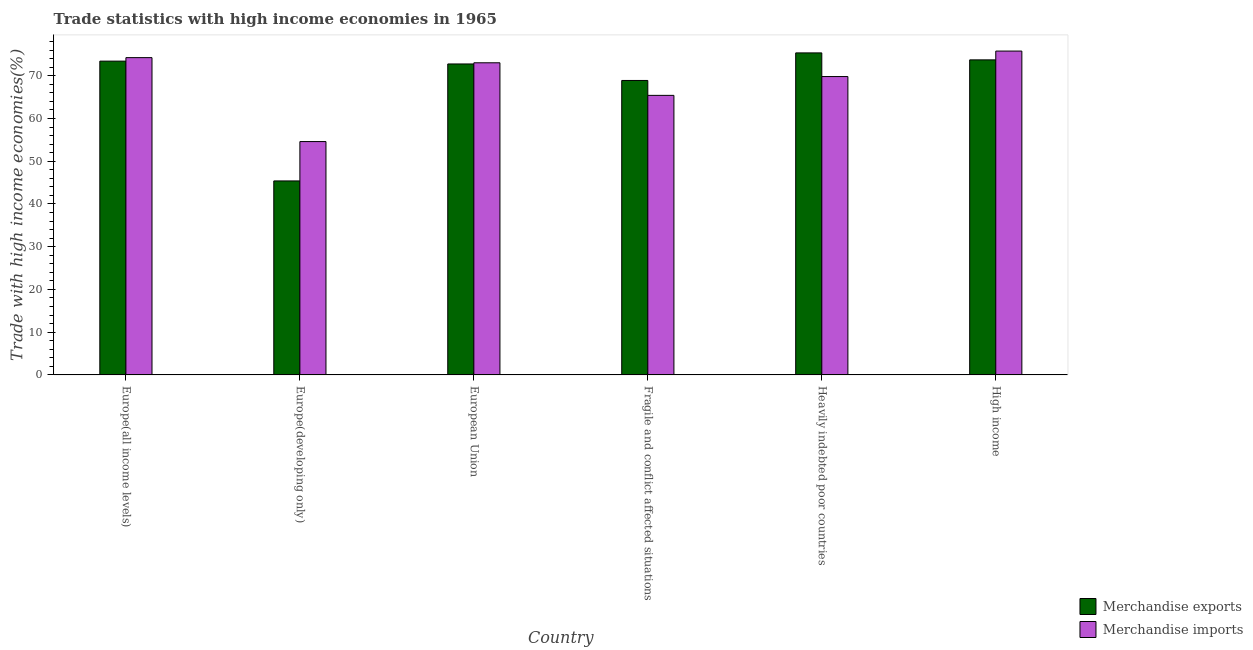How many groups of bars are there?
Your answer should be compact. 6. Are the number of bars per tick equal to the number of legend labels?
Provide a short and direct response. Yes. How many bars are there on the 2nd tick from the right?
Your answer should be compact. 2. What is the label of the 2nd group of bars from the left?
Give a very brief answer. Europe(developing only). What is the merchandise imports in Heavily indebted poor countries?
Your answer should be very brief. 69.82. Across all countries, what is the maximum merchandise imports?
Your answer should be compact. 75.78. Across all countries, what is the minimum merchandise imports?
Give a very brief answer. 54.6. In which country was the merchandise imports minimum?
Your answer should be very brief. Europe(developing only). What is the total merchandise exports in the graph?
Provide a short and direct response. 409.57. What is the difference between the merchandise exports in Europe(all income levels) and that in Europe(developing only)?
Your answer should be very brief. 28.04. What is the difference between the merchandise imports in Europe(all income levels) and the merchandise exports in Europe(developing only)?
Ensure brevity in your answer.  28.85. What is the average merchandise imports per country?
Provide a succinct answer. 68.82. What is the difference between the merchandise imports and merchandise exports in High income?
Offer a terse response. 2.06. What is the ratio of the merchandise exports in Europe(all income levels) to that in European Union?
Provide a succinct answer. 1.01. Is the difference between the merchandise exports in Europe(all income levels) and Europe(developing only) greater than the difference between the merchandise imports in Europe(all income levels) and Europe(developing only)?
Your answer should be very brief. Yes. What is the difference between the highest and the second highest merchandise imports?
Ensure brevity in your answer.  1.54. What is the difference between the highest and the lowest merchandise exports?
Make the answer very short. 29.96. Is the sum of the merchandise imports in European Union and High income greater than the maximum merchandise exports across all countries?
Your response must be concise. Yes. Are the values on the major ticks of Y-axis written in scientific E-notation?
Make the answer very short. No. How many legend labels are there?
Provide a short and direct response. 2. What is the title of the graph?
Offer a very short reply. Trade statistics with high income economies in 1965. What is the label or title of the Y-axis?
Your response must be concise. Trade with high income economies(%). What is the Trade with high income economies(%) in Merchandise exports in Europe(all income levels)?
Ensure brevity in your answer.  73.43. What is the Trade with high income economies(%) in Merchandise imports in Europe(all income levels)?
Keep it short and to the point. 74.25. What is the Trade with high income economies(%) of Merchandise exports in Europe(developing only)?
Ensure brevity in your answer.  45.39. What is the Trade with high income economies(%) of Merchandise imports in Europe(developing only)?
Your response must be concise. 54.6. What is the Trade with high income economies(%) of Merchandise exports in European Union?
Your answer should be very brief. 72.77. What is the Trade with high income economies(%) of Merchandise imports in European Union?
Your response must be concise. 73.04. What is the Trade with high income economies(%) of Merchandise exports in Fragile and conflict affected situations?
Your answer should be compact. 68.9. What is the Trade with high income economies(%) of Merchandise imports in Fragile and conflict affected situations?
Give a very brief answer. 65.42. What is the Trade with high income economies(%) of Merchandise exports in Heavily indebted poor countries?
Offer a very short reply. 75.35. What is the Trade with high income economies(%) of Merchandise imports in Heavily indebted poor countries?
Make the answer very short. 69.82. What is the Trade with high income economies(%) of Merchandise exports in High income?
Offer a terse response. 73.72. What is the Trade with high income economies(%) of Merchandise imports in High income?
Offer a very short reply. 75.78. Across all countries, what is the maximum Trade with high income economies(%) of Merchandise exports?
Offer a terse response. 75.35. Across all countries, what is the maximum Trade with high income economies(%) of Merchandise imports?
Your response must be concise. 75.78. Across all countries, what is the minimum Trade with high income economies(%) of Merchandise exports?
Provide a short and direct response. 45.39. Across all countries, what is the minimum Trade with high income economies(%) in Merchandise imports?
Ensure brevity in your answer.  54.6. What is the total Trade with high income economies(%) of Merchandise exports in the graph?
Your answer should be compact. 409.57. What is the total Trade with high income economies(%) of Merchandise imports in the graph?
Keep it short and to the point. 412.91. What is the difference between the Trade with high income economies(%) in Merchandise exports in Europe(all income levels) and that in Europe(developing only)?
Keep it short and to the point. 28.04. What is the difference between the Trade with high income economies(%) in Merchandise imports in Europe(all income levels) and that in Europe(developing only)?
Offer a very short reply. 19.64. What is the difference between the Trade with high income economies(%) in Merchandise exports in Europe(all income levels) and that in European Union?
Give a very brief answer. 0.66. What is the difference between the Trade with high income economies(%) of Merchandise imports in Europe(all income levels) and that in European Union?
Ensure brevity in your answer.  1.2. What is the difference between the Trade with high income economies(%) of Merchandise exports in Europe(all income levels) and that in Fragile and conflict affected situations?
Your answer should be very brief. 4.52. What is the difference between the Trade with high income economies(%) of Merchandise imports in Europe(all income levels) and that in Fragile and conflict affected situations?
Keep it short and to the point. 8.83. What is the difference between the Trade with high income economies(%) of Merchandise exports in Europe(all income levels) and that in Heavily indebted poor countries?
Provide a succinct answer. -1.93. What is the difference between the Trade with high income economies(%) of Merchandise imports in Europe(all income levels) and that in Heavily indebted poor countries?
Your answer should be very brief. 4.43. What is the difference between the Trade with high income economies(%) of Merchandise exports in Europe(all income levels) and that in High income?
Your response must be concise. -0.29. What is the difference between the Trade with high income economies(%) of Merchandise imports in Europe(all income levels) and that in High income?
Give a very brief answer. -1.54. What is the difference between the Trade with high income economies(%) in Merchandise exports in Europe(developing only) and that in European Union?
Give a very brief answer. -27.37. What is the difference between the Trade with high income economies(%) in Merchandise imports in Europe(developing only) and that in European Union?
Your response must be concise. -18.44. What is the difference between the Trade with high income economies(%) of Merchandise exports in Europe(developing only) and that in Fragile and conflict affected situations?
Offer a very short reply. -23.51. What is the difference between the Trade with high income economies(%) in Merchandise imports in Europe(developing only) and that in Fragile and conflict affected situations?
Provide a succinct answer. -10.81. What is the difference between the Trade with high income economies(%) in Merchandise exports in Europe(developing only) and that in Heavily indebted poor countries?
Your response must be concise. -29.96. What is the difference between the Trade with high income economies(%) of Merchandise imports in Europe(developing only) and that in Heavily indebted poor countries?
Provide a short and direct response. -15.22. What is the difference between the Trade with high income economies(%) of Merchandise exports in Europe(developing only) and that in High income?
Keep it short and to the point. -28.33. What is the difference between the Trade with high income economies(%) of Merchandise imports in Europe(developing only) and that in High income?
Your answer should be compact. -21.18. What is the difference between the Trade with high income economies(%) of Merchandise exports in European Union and that in Fragile and conflict affected situations?
Your answer should be compact. 3.86. What is the difference between the Trade with high income economies(%) in Merchandise imports in European Union and that in Fragile and conflict affected situations?
Keep it short and to the point. 7.62. What is the difference between the Trade with high income economies(%) in Merchandise exports in European Union and that in Heavily indebted poor countries?
Provide a short and direct response. -2.59. What is the difference between the Trade with high income economies(%) of Merchandise imports in European Union and that in Heavily indebted poor countries?
Make the answer very short. 3.22. What is the difference between the Trade with high income economies(%) of Merchandise exports in European Union and that in High income?
Keep it short and to the point. -0.96. What is the difference between the Trade with high income economies(%) in Merchandise imports in European Union and that in High income?
Your response must be concise. -2.74. What is the difference between the Trade with high income economies(%) of Merchandise exports in Fragile and conflict affected situations and that in Heavily indebted poor countries?
Make the answer very short. -6.45. What is the difference between the Trade with high income economies(%) of Merchandise imports in Fragile and conflict affected situations and that in Heavily indebted poor countries?
Ensure brevity in your answer.  -4.4. What is the difference between the Trade with high income economies(%) in Merchandise exports in Fragile and conflict affected situations and that in High income?
Provide a short and direct response. -4.82. What is the difference between the Trade with high income economies(%) of Merchandise imports in Fragile and conflict affected situations and that in High income?
Provide a short and direct response. -10.37. What is the difference between the Trade with high income economies(%) of Merchandise exports in Heavily indebted poor countries and that in High income?
Your answer should be compact. 1.63. What is the difference between the Trade with high income economies(%) of Merchandise imports in Heavily indebted poor countries and that in High income?
Offer a terse response. -5.96. What is the difference between the Trade with high income economies(%) in Merchandise exports in Europe(all income levels) and the Trade with high income economies(%) in Merchandise imports in Europe(developing only)?
Make the answer very short. 18.82. What is the difference between the Trade with high income economies(%) in Merchandise exports in Europe(all income levels) and the Trade with high income economies(%) in Merchandise imports in European Union?
Your answer should be compact. 0.39. What is the difference between the Trade with high income economies(%) of Merchandise exports in Europe(all income levels) and the Trade with high income economies(%) of Merchandise imports in Fragile and conflict affected situations?
Provide a short and direct response. 8.01. What is the difference between the Trade with high income economies(%) in Merchandise exports in Europe(all income levels) and the Trade with high income economies(%) in Merchandise imports in Heavily indebted poor countries?
Keep it short and to the point. 3.61. What is the difference between the Trade with high income economies(%) of Merchandise exports in Europe(all income levels) and the Trade with high income economies(%) of Merchandise imports in High income?
Offer a terse response. -2.35. What is the difference between the Trade with high income economies(%) in Merchandise exports in Europe(developing only) and the Trade with high income economies(%) in Merchandise imports in European Union?
Your response must be concise. -27.65. What is the difference between the Trade with high income economies(%) in Merchandise exports in Europe(developing only) and the Trade with high income economies(%) in Merchandise imports in Fragile and conflict affected situations?
Provide a succinct answer. -20.02. What is the difference between the Trade with high income economies(%) in Merchandise exports in Europe(developing only) and the Trade with high income economies(%) in Merchandise imports in Heavily indebted poor countries?
Your answer should be compact. -24.43. What is the difference between the Trade with high income economies(%) in Merchandise exports in Europe(developing only) and the Trade with high income economies(%) in Merchandise imports in High income?
Keep it short and to the point. -30.39. What is the difference between the Trade with high income economies(%) in Merchandise exports in European Union and the Trade with high income economies(%) in Merchandise imports in Fragile and conflict affected situations?
Ensure brevity in your answer.  7.35. What is the difference between the Trade with high income economies(%) of Merchandise exports in European Union and the Trade with high income economies(%) of Merchandise imports in Heavily indebted poor countries?
Your response must be concise. 2.95. What is the difference between the Trade with high income economies(%) in Merchandise exports in European Union and the Trade with high income economies(%) in Merchandise imports in High income?
Your answer should be compact. -3.02. What is the difference between the Trade with high income economies(%) of Merchandise exports in Fragile and conflict affected situations and the Trade with high income economies(%) of Merchandise imports in Heavily indebted poor countries?
Your response must be concise. -0.92. What is the difference between the Trade with high income economies(%) of Merchandise exports in Fragile and conflict affected situations and the Trade with high income economies(%) of Merchandise imports in High income?
Ensure brevity in your answer.  -6.88. What is the difference between the Trade with high income economies(%) in Merchandise exports in Heavily indebted poor countries and the Trade with high income economies(%) in Merchandise imports in High income?
Your answer should be very brief. -0.43. What is the average Trade with high income economies(%) in Merchandise exports per country?
Your answer should be very brief. 68.26. What is the average Trade with high income economies(%) of Merchandise imports per country?
Keep it short and to the point. 68.82. What is the difference between the Trade with high income economies(%) in Merchandise exports and Trade with high income economies(%) in Merchandise imports in Europe(all income levels)?
Offer a terse response. -0.82. What is the difference between the Trade with high income economies(%) of Merchandise exports and Trade with high income economies(%) of Merchandise imports in Europe(developing only)?
Keep it short and to the point. -9.21. What is the difference between the Trade with high income economies(%) in Merchandise exports and Trade with high income economies(%) in Merchandise imports in European Union?
Provide a short and direct response. -0.27. What is the difference between the Trade with high income economies(%) of Merchandise exports and Trade with high income economies(%) of Merchandise imports in Fragile and conflict affected situations?
Make the answer very short. 3.49. What is the difference between the Trade with high income economies(%) of Merchandise exports and Trade with high income economies(%) of Merchandise imports in Heavily indebted poor countries?
Provide a short and direct response. 5.53. What is the difference between the Trade with high income economies(%) in Merchandise exports and Trade with high income economies(%) in Merchandise imports in High income?
Your response must be concise. -2.06. What is the ratio of the Trade with high income economies(%) of Merchandise exports in Europe(all income levels) to that in Europe(developing only)?
Provide a short and direct response. 1.62. What is the ratio of the Trade with high income economies(%) of Merchandise imports in Europe(all income levels) to that in Europe(developing only)?
Make the answer very short. 1.36. What is the ratio of the Trade with high income economies(%) of Merchandise exports in Europe(all income levels) to that in European Union?
Offer a very short reply. 1.01. What is the ratio of the Trade with high income economies(%) in Merchandise imports in Europe(all income levels) to that in European Union?
Your response must be concise. 1.02. What is the ratio of the Trade with high income economies(%) in Merchandise exports in Europe(all income levels) to that in Fragile and conflict affected situations?
Your answer should be compact. 1.07. What is the ratio of the Trade with high income economies(%) in Merchandise imports in Europe(all income levels) to that in Fragile and conflict affected situations?
Give a very brief answer. 1.14. What is the ratio of the Trade with high income economies(%) of Merchandise exports in Europe(all income levels) to that in Heavily indebted poor countries?
Provide a succinct answer. 0.97. What is the ratio of the Trade with high income economies(%) in Merchandise imports in Europe(all income levels) to that in Heavily indebted poor countries?
Keep it short and to the point. 1.06. What is the ratio of the Trade with high income economies(%) of Merchandise exports in Europe(all income levels) to that in High income?
Give a very brief answer. 1. What is the ratio of the Trade with high income economies(%) of Merchandise imports in Europe(all income levels) to that in High income?
Give a very brief answer. 0.98. What is the ratio of the Trade with high income economies(%) in Merchandise exports in Europe(developing only) to that in European Union?
Provide a short and direct response. 0.62. What is the ratio of the Trade with high income economies(%) in Merchandise imports in Europe(developing only) to that in European Union?
Provide a succinct answer. 0.75. What is the ratio of the Trade with high income economies(%) of Merchandise exports in Europe(developing only) to that in Fragile and conflict affected situations?
Ensure brevity in your answer.  0.66. What is the ratio of the Trade with high income economies(%) in Merchandise imports in Europe(developing only) to that in Fragile and conflict affected situations?
Your response must be concise. 0.83. What is the ratio of the Trade with high income economies(%) in Merchandise exports in Europe(developing only) to that in Heavily indebted poor countries?
Offer a very short reply. 0.6. What is the ratio of the Trade with high income economies(%) in Merchandise imports in Europe(developing only) to that in Heavily indebted poor countries?
Offer a terse response. 0.78. What is the ratio of the Trade with high income economies(%) of Merchandise exports in Europe(developing only) to that in High income?
Your answer should be compact. 0.62. What is the ratio of the Trade with high income economies(%) of Merchandise imports in Europe(developing only) to that in High income?
Ensure brevity in your answer.  0.72. What is the ratio of the Trade with high income economies(%) of Merchandise exports in European Union to that in Fragile and conflict affected situations?
Offer a very short reply. 1.06. What is the ratio of the Trade with high income economies(%) in Merchandise imports in European Union to that in Fragile and conflict affected situations?
Make the answer very short. 1.12. What is the ratio of the Trade with high income economies(%) in Merchandise exports in European Union to that in Heavily indebted poor countries?
Give a very brief answer. 0.97. What is the ratio of the Trade with high income economies(%) in Merchandise imports in European Union to that in Heavily indebted poor countries?
Your response must be concise. 1.05. What is the ratio of the Trade with high income economies(%) of Merchandise imports in European Union to that in High income?
Keep it short and to the point. 0.96. What is the ratio of the Trade with high income economies(%) in Merchandise exports in Fragile and conflict affected situations to that in Heavily indebted poor countries?
Make the answer very short. 0.91. What is the ratio of the Trade with high income economies(%) in Merchandise imports in Fragile and conflict affected situations to that in Heavily indebted poor countries?
Your answer should be compact. 0.94. What is the ratio of the Trade with high income economies(%) of Merchandise exports in Fragile and conflict affected situations to that in High income?
Provide a succinct answer. 0.93. What is the ratio of the Trade with high income economies(%) in Merchandise imports in Fragile and conflict affected situations to that in High income?
Keep it short and to the point. 0.86. What is the ratio of the Trade with high income economies(%) of Merchandise exports in Heavily indebted poor countries to that in High income?
Ensure brevity in your answer.  1.02. What is the ratio of the Trade with high income economies(%) in Merchandise imports in Heavily indebted poor countries to that in High income?
Ensure brevity in your answer.  0.92. What is the difference between the highest and the second highest Trade with high income economies(%) of Merchandise exports?
Give a very brief answer. 1.63. What is the difference between the highest and the second highest Trade with high income economies(%) of Merchandise imports?
Offer a terse response. 1.54. What is the difference between the highest and the lowest Trade with high income economies(%) of Merchandise exports?
Give a very brief answer. 29.96. What is the difference between the highest and the lowest Trade with high income economies(%) in Merchandise imports?
Your response must be concise. 21.18. 